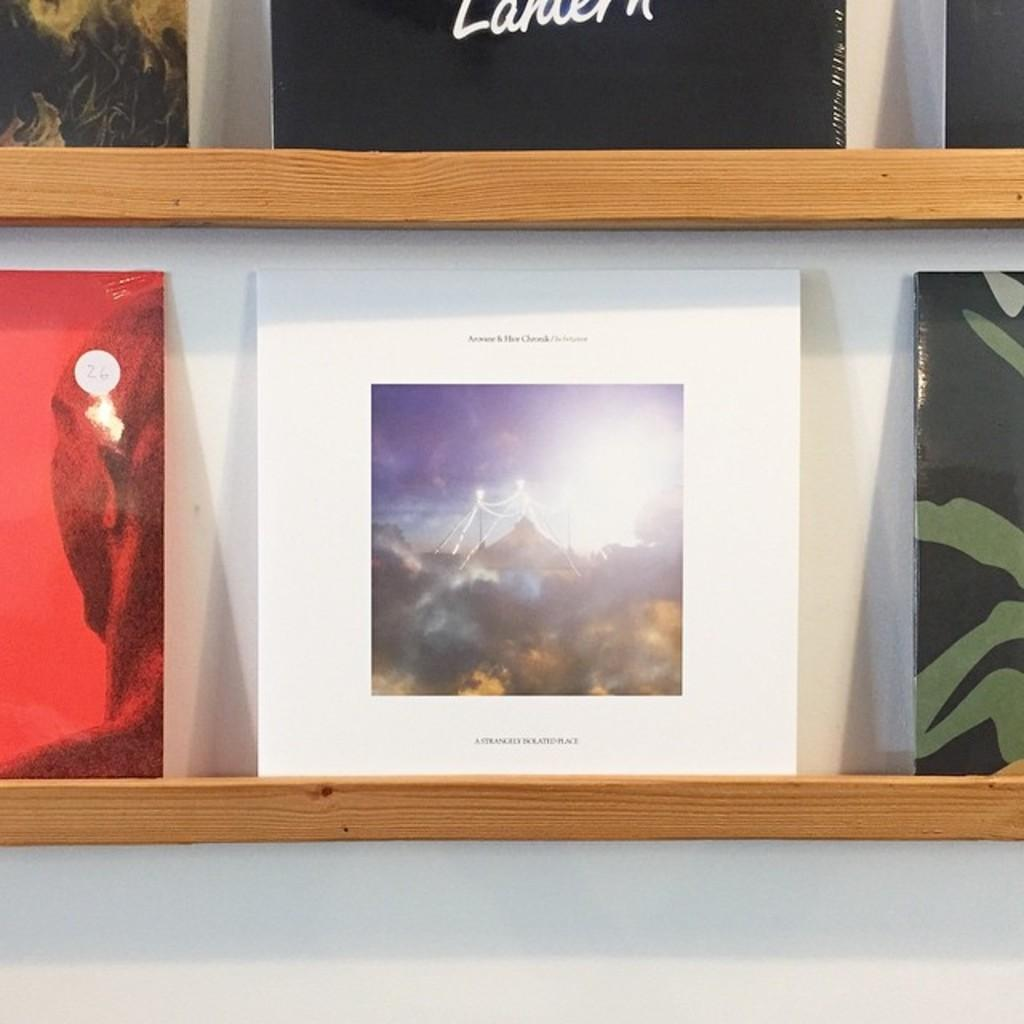<image>
Create a compact narrative representing the image presented. White cover under a black cover that says Lauren on it. 